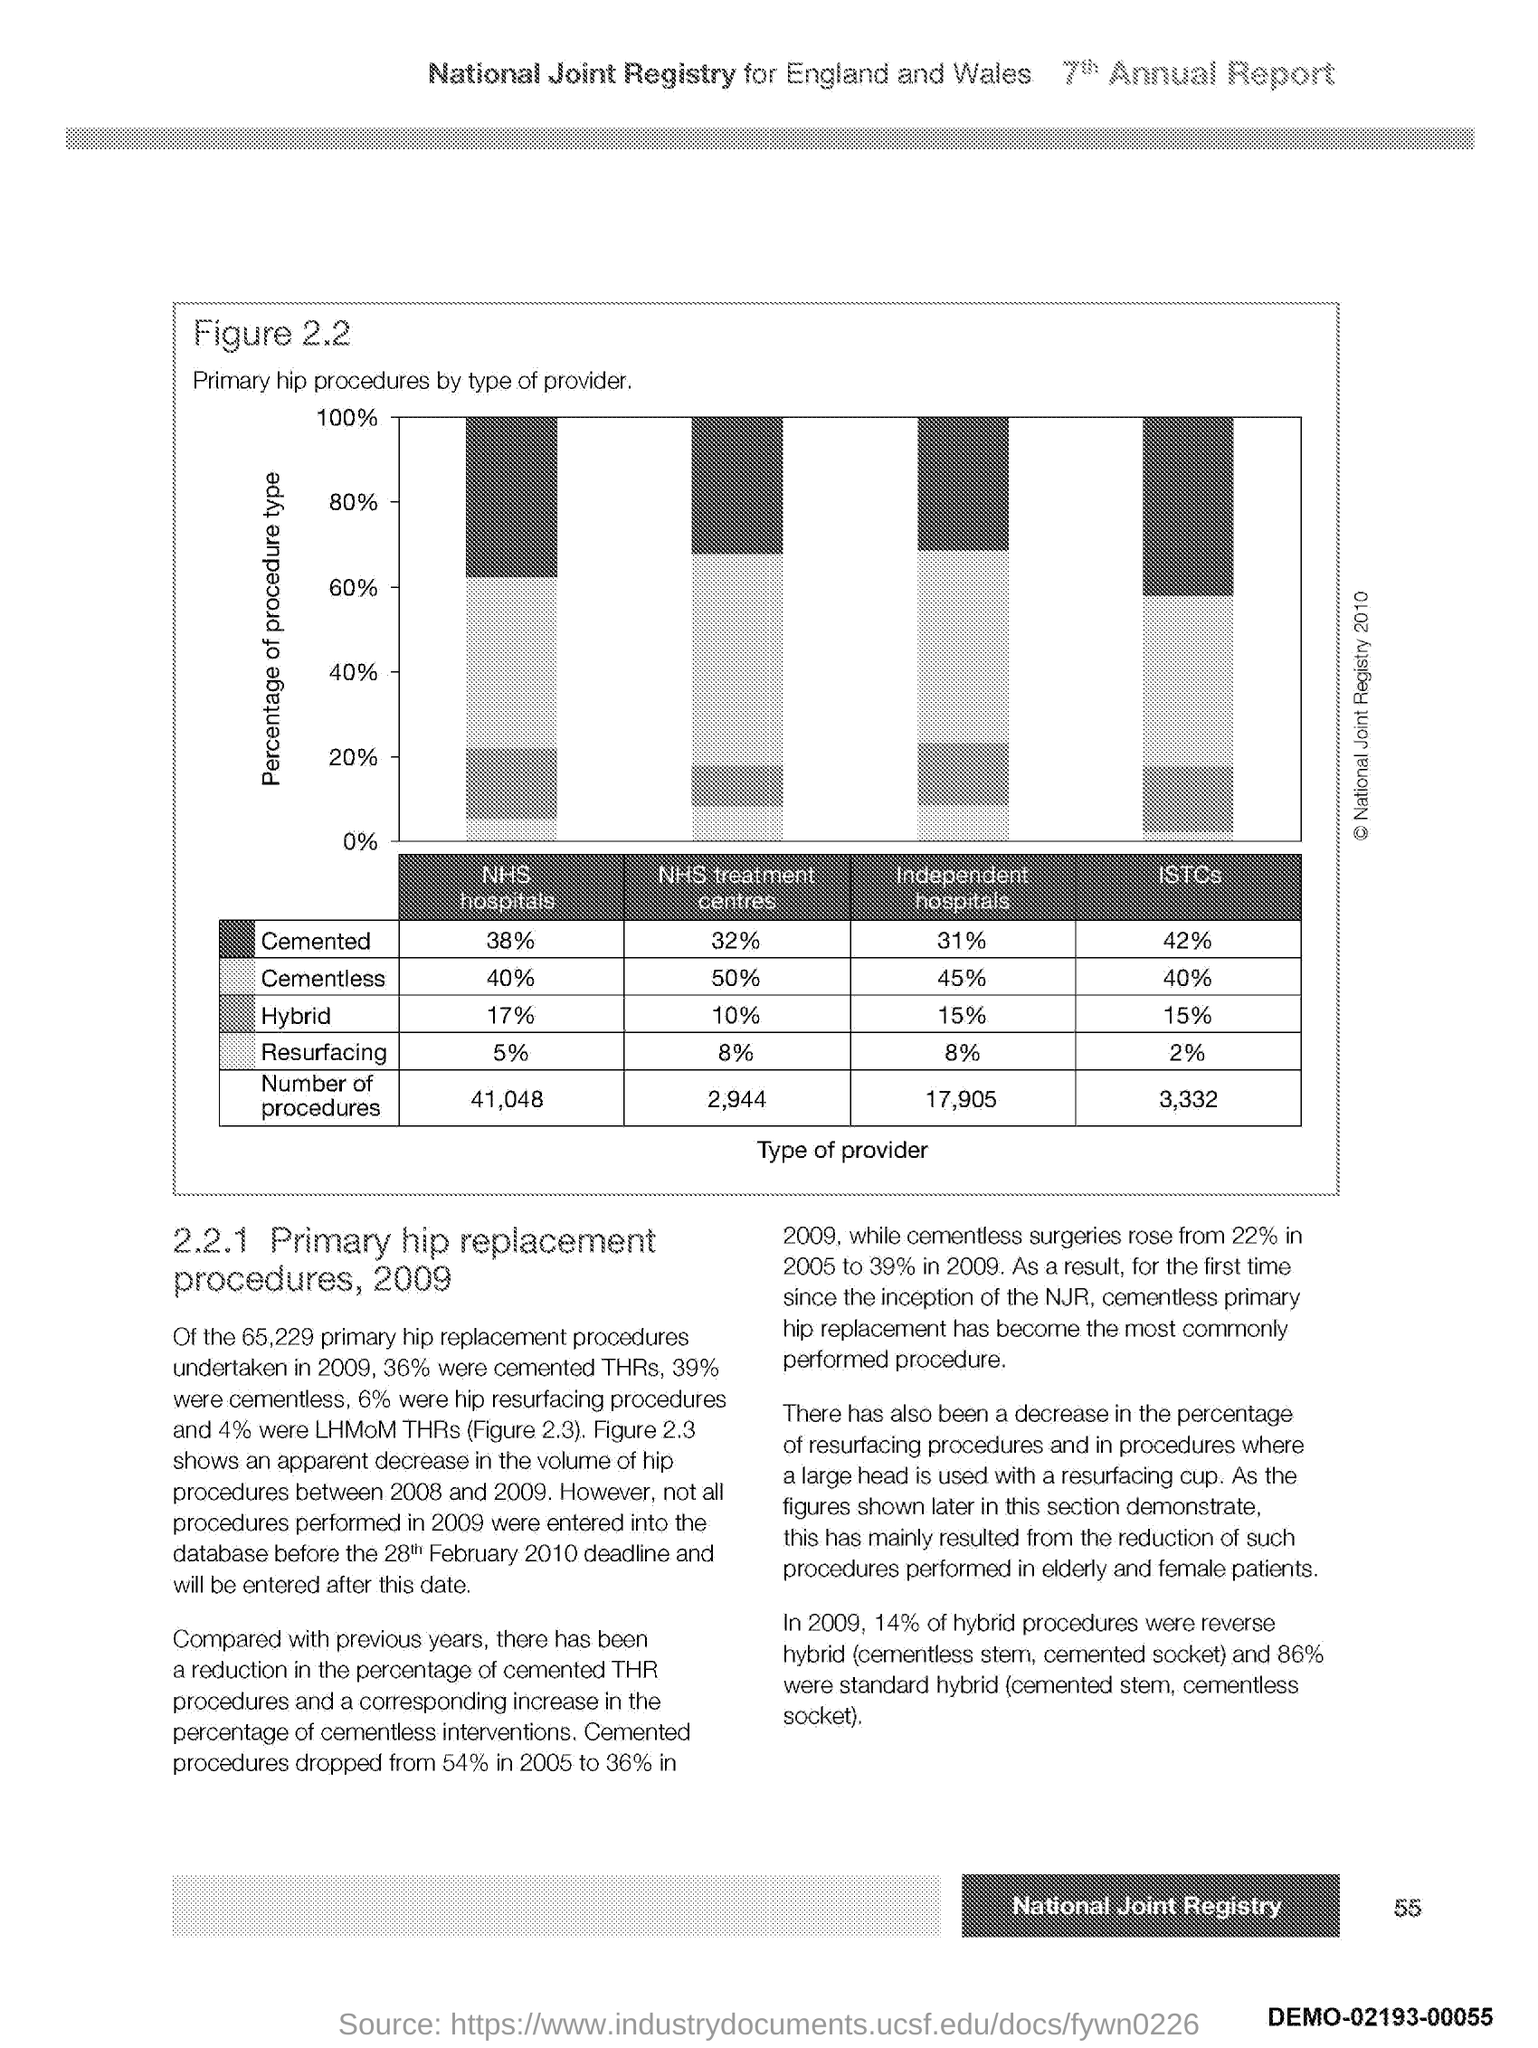Specify some key components in this picture. The y-axis shows the percentage of procedure types. 